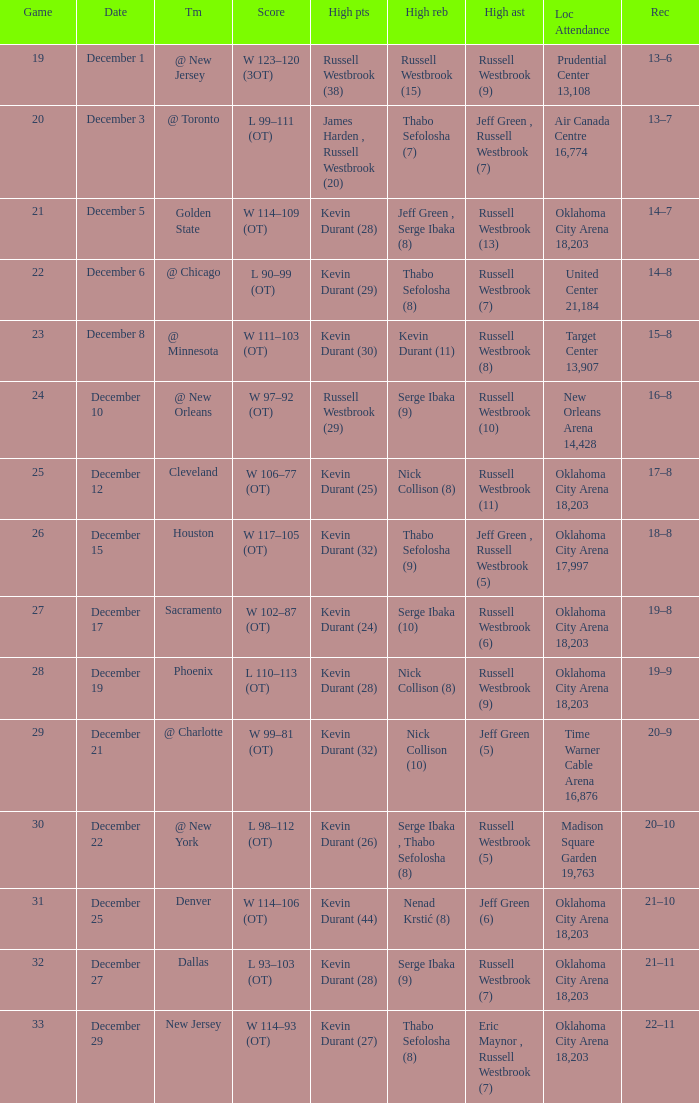Who had the high rebounds record on December 12? Nick Collison (8). 